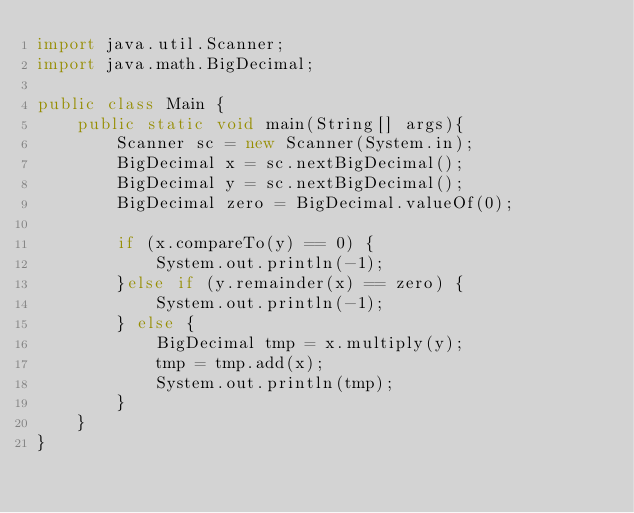<code> <loc_0><loc_0><loc_500><loc_500><_Java_>import java.util.Scanner;
import java.math.BigDecimal;

public class Main {
    public static void main(String[] args){
        Scanner sc = new Scanner(System.in);
        BigDecimal x = sc.nextBigDecimal();
        BigDecimal y = sc.nextBigDecimal();
        BigDecimal zero = BigDecimal.valueOf(0);

        if (x.compareTo(y) == 0) {
            System.out.println(-1);
        }else if (y.remainder(x) == zero) {
            System.out.println(-1);
        } else {
            BigDecimal tmp = x.multiply(y);
            tmp = tmp.add(x);
            System.out.println(tmp);
        }
    }
}</code> 